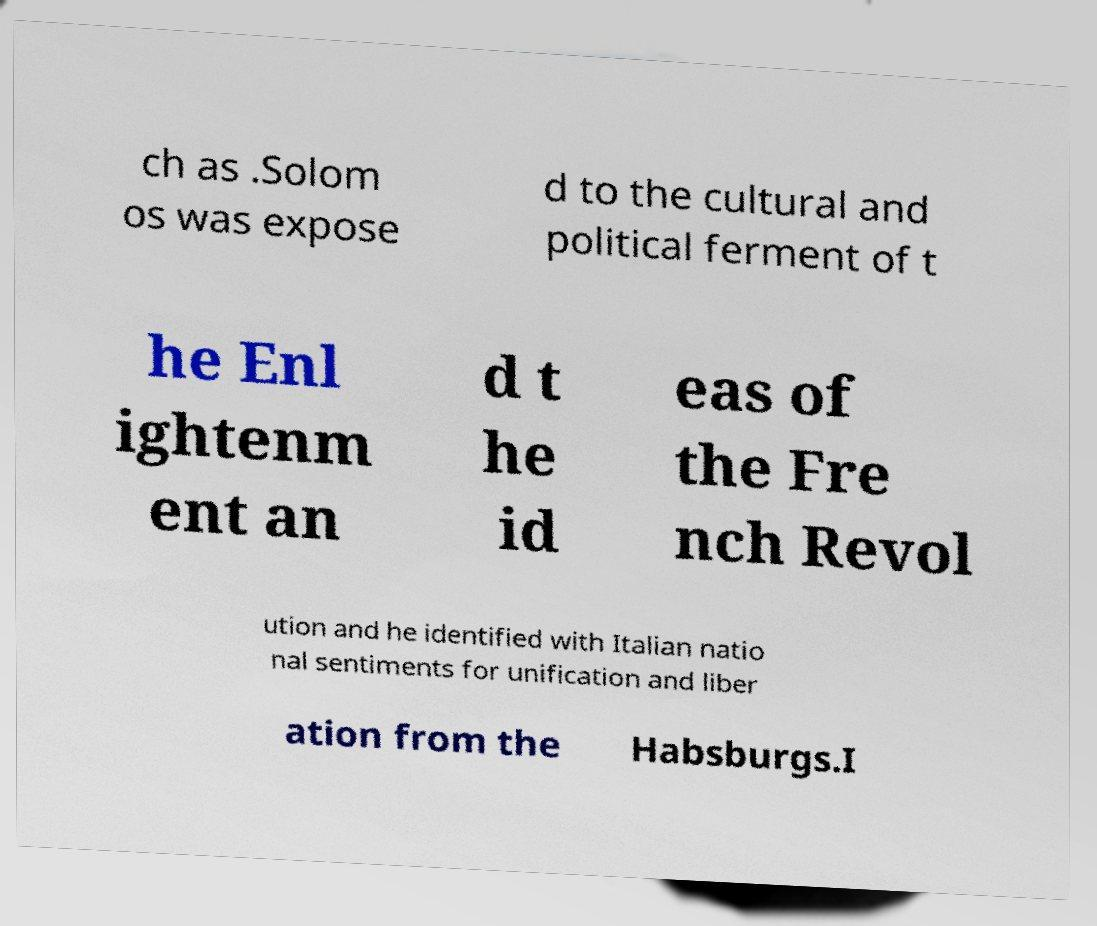Please identify and transcribe the text found in this image. ch as .Solom os was expose d to the cultural and political ferment of t he Enl ightenm ent an d t he id eas of the Fre nch Revol ution and he identified with Italian natio nal sentiments for unification and liber ation from the Habsburgs.I 